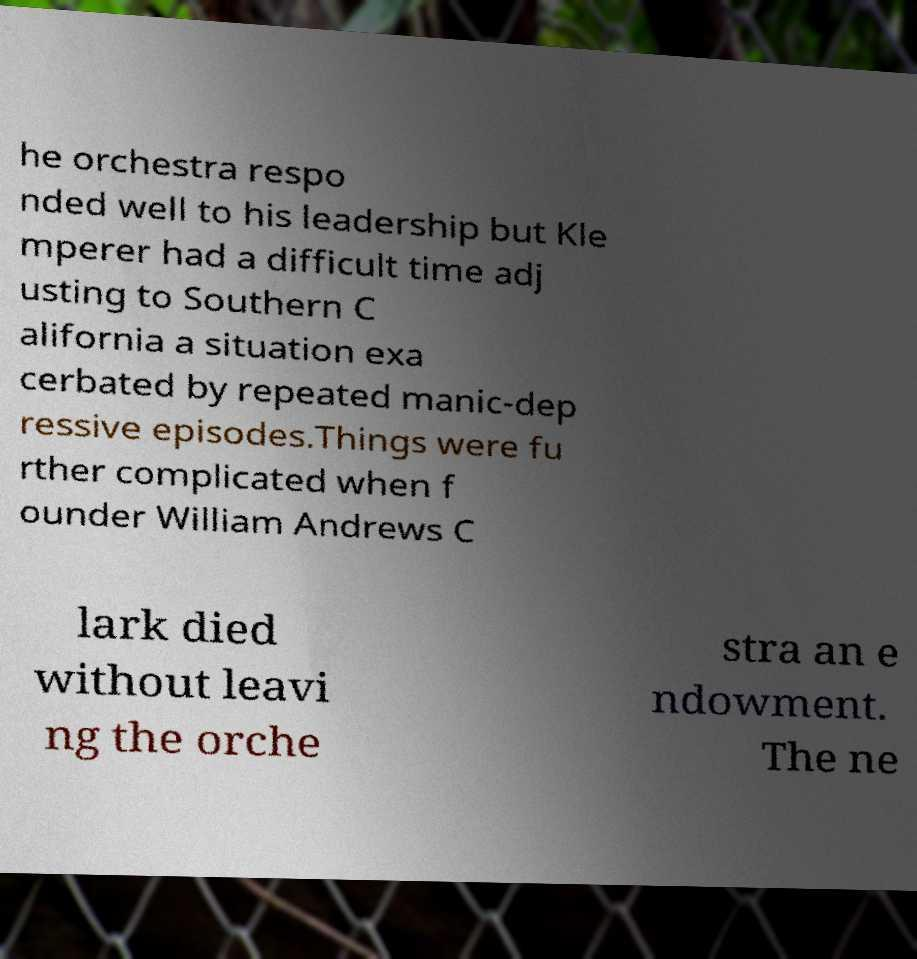For documentation purposes, I need the text within this image transcribed. Could you provide that? he orchestra respo nded well to his leadership but Kle mperer had a difficult time adj usting to Southern C alifornia a situation exa cerbated by repeated manic-dep ressive episodes.Things were fu rther complicated when f ounder William Andrews C lark died without leavi ng the orche stra an e ndowment. The ne 